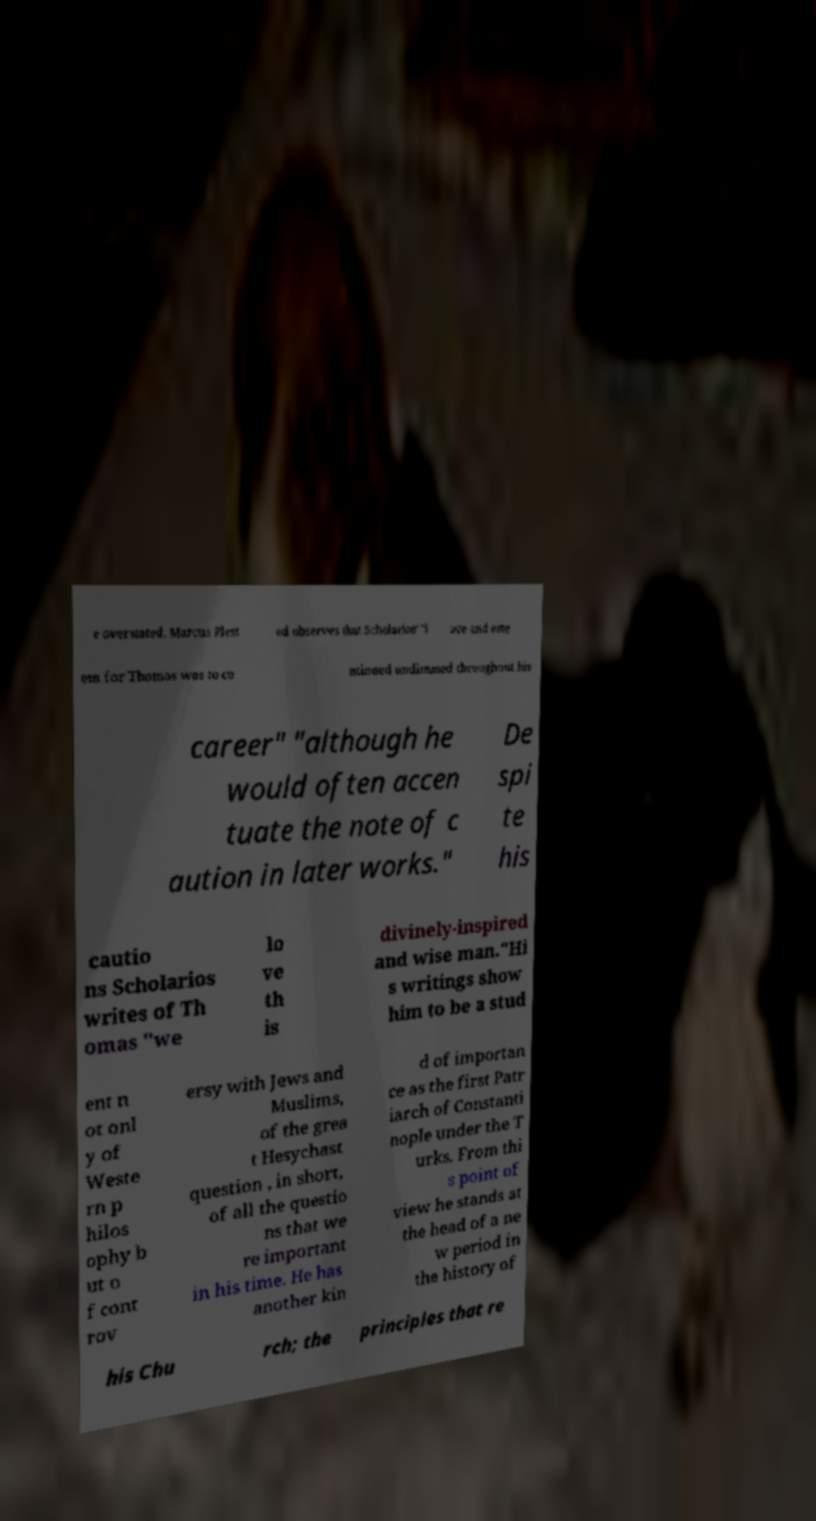Could you assist in decoding the text presented in this image and type it out clearly? e overstated. Marcus Plest ed observes that Scholarios' "l ove and este em for Thomas was to co ntinued undimmed throughout his career" "although he would often accen tuate the note of c aution in later works." De spi te his cautio ns Scholarios writes of Th omas "we lo ve th is divinely-inspired and wise man."Hi s writings show him to be a stud ent n ot onl y of Weste rn p hilos ophy b ut o f cont rov ersy with Jews and Muslims, of the grea t Hesychast question , in short, of all the questio ns that we re important in his time. He has another kin d of importan ce as the first Patr iarch of Constanti nople under the T urks. From thi s point of view he stands at the head of a ne w period in the history of his Chu rch; the principles that re 